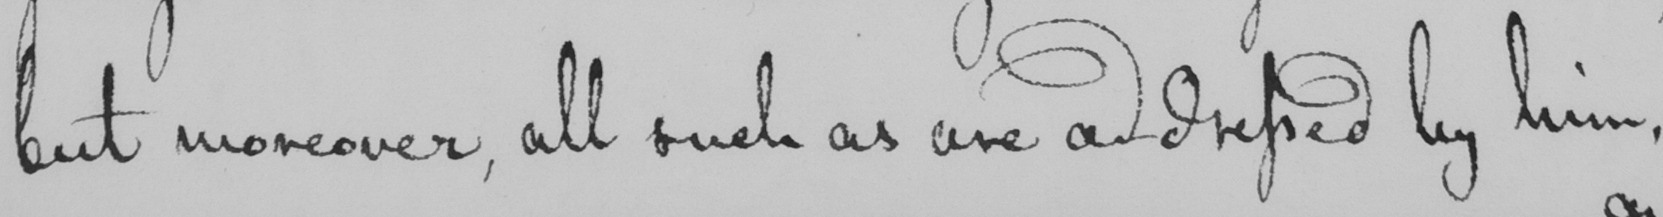Transcribe the text shown in this historical manuscript line. but moreover , all such as are addressed by him , 